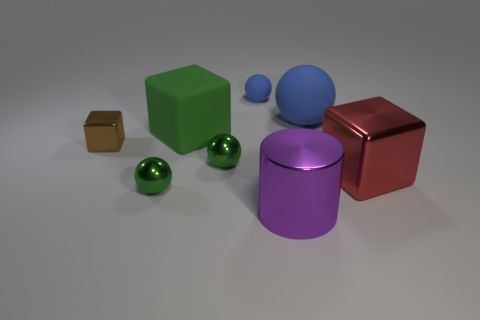Is the color of the small matte object the same as the large matte object that is right of the large purple metallic cylinder?
Provide a succinct answer. Yes. Is there another rubber thing that has the same color as the small matte thing?
Offer a very short reply. Yes. What is the material of the large ball?
Offer a very short reply. Rubber. There is another sphere that is the same color as the big rubber sphere; what is its material?
Your answer should be very brief. Rubber. How many other things are made of the same material as the big red thing?
Provide a short and direct response. 4. What is the shape of the metal thing that is both right of the big green object and behind the big red shiny object?
Ensure brevity in your answer.  Sphere. What is the color of the other large thing that is made of the same material as the red thing?
Make the answer very short. Purple. Are there the same number of brown shiny cubes that are right of the big matte ball and blue matte balls?
Provide a succinct answer. No. There is a shiny thing that is the same size as the shiny cylinder; what shape is it?
Offer a very short reply. Cube. What number of other things are there of the same shape as the big blue object?
Make the answer very short. 3. 